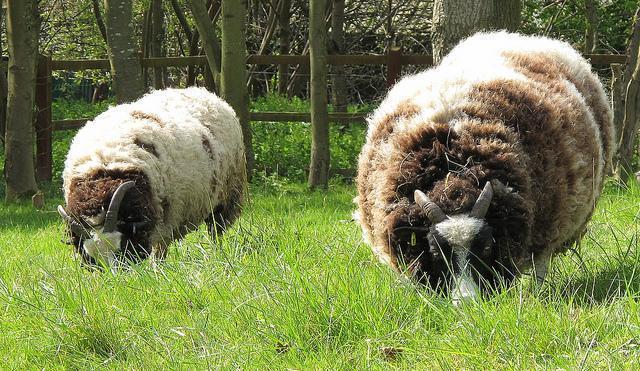How many sheep are in the photo?
Give a very brief answer. 2. 